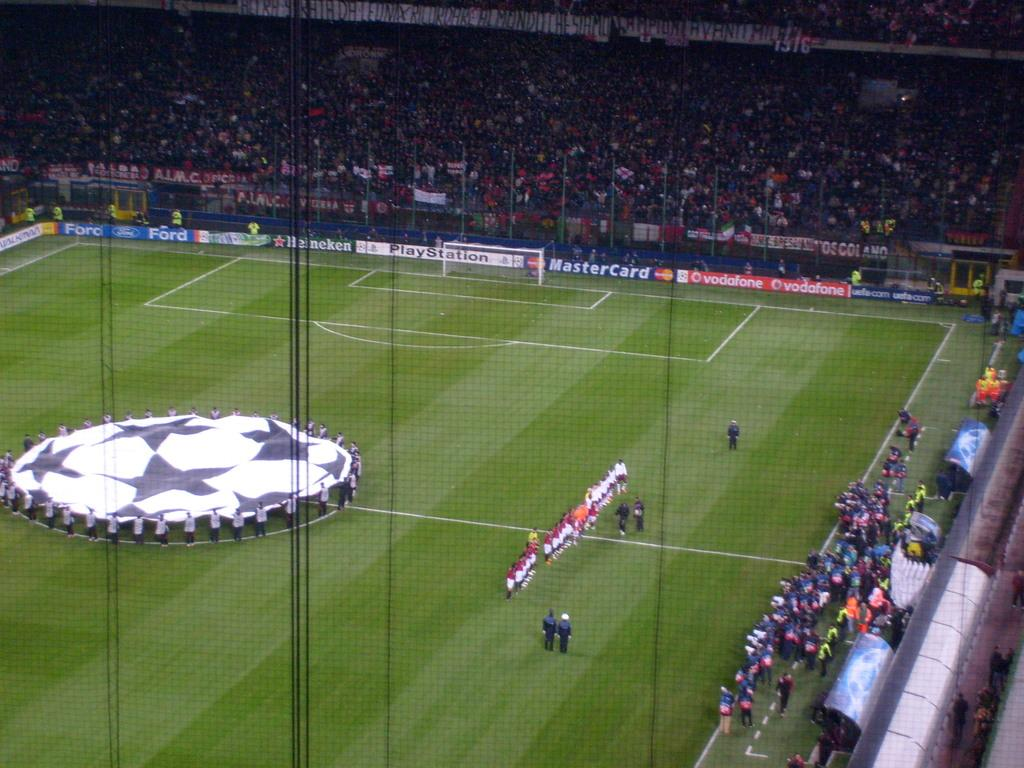<image>
Present a compact description of the photo's key features. A soccer field with banners from Mastercard and Play Station. 